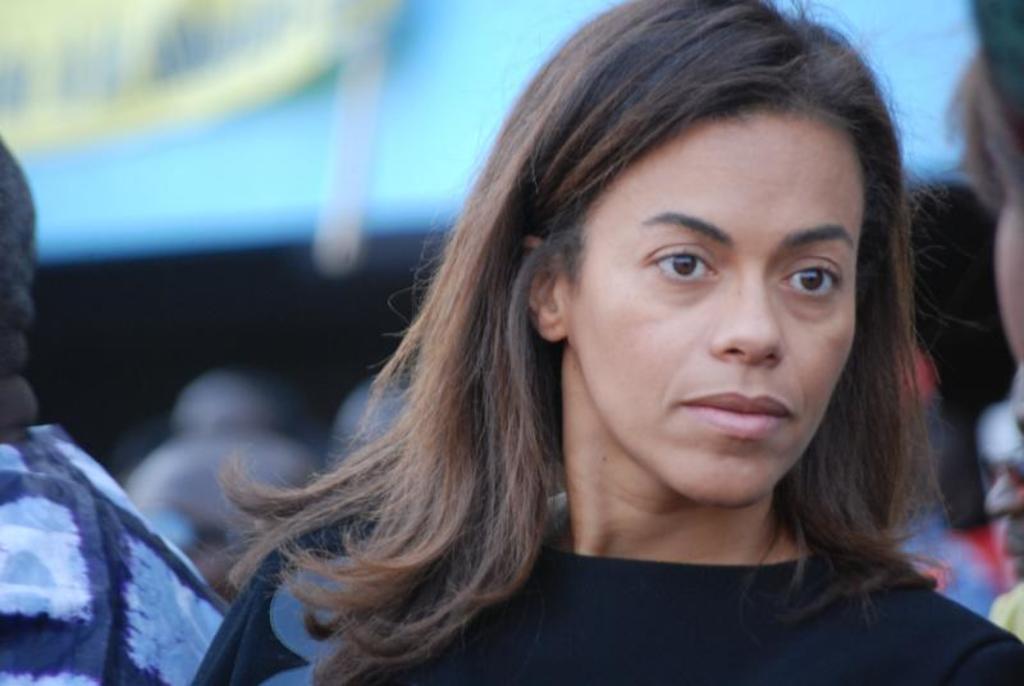In one or two sentences, can you explain what this image depicts? Bottom right side of the image a woman is standing. Behind her few people are standing. 